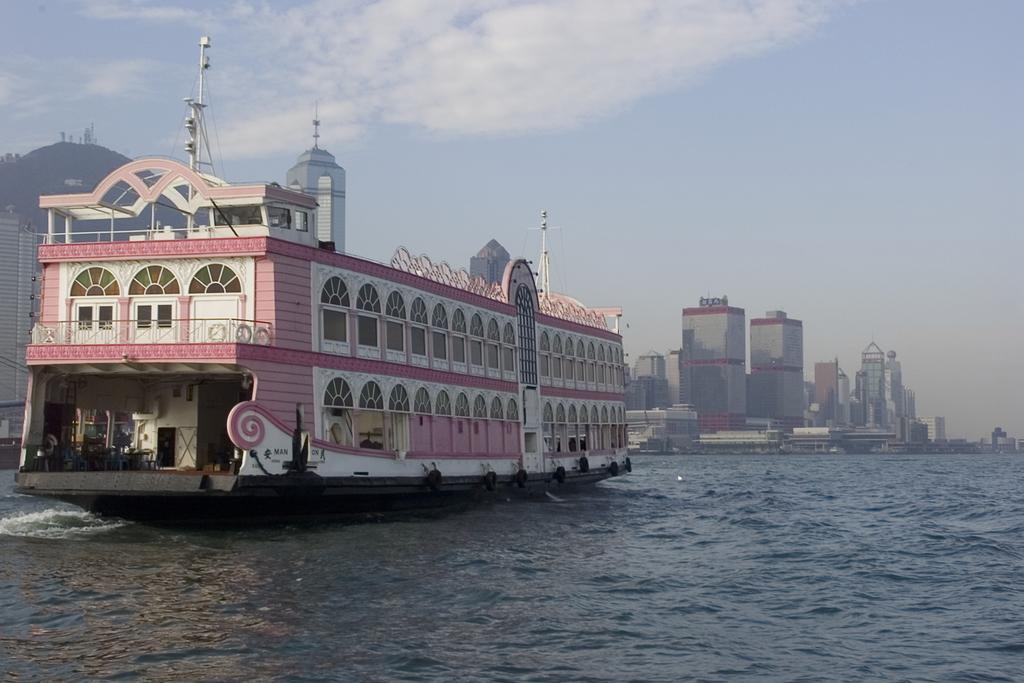What is the main subject in the center of the image? There is a boat in the center of the image. What type of structures can be seen in the image? There are buildings and a tower in the image. What is visible in the sky at the top of the image? Clouds are present in the sky at the top of the image. What is visible at the bottom of the image? Water is visible at the bottom of the image. Can you tell me which actor is sitting on the zebra in the image? There is no actor or zebra present in the image. 